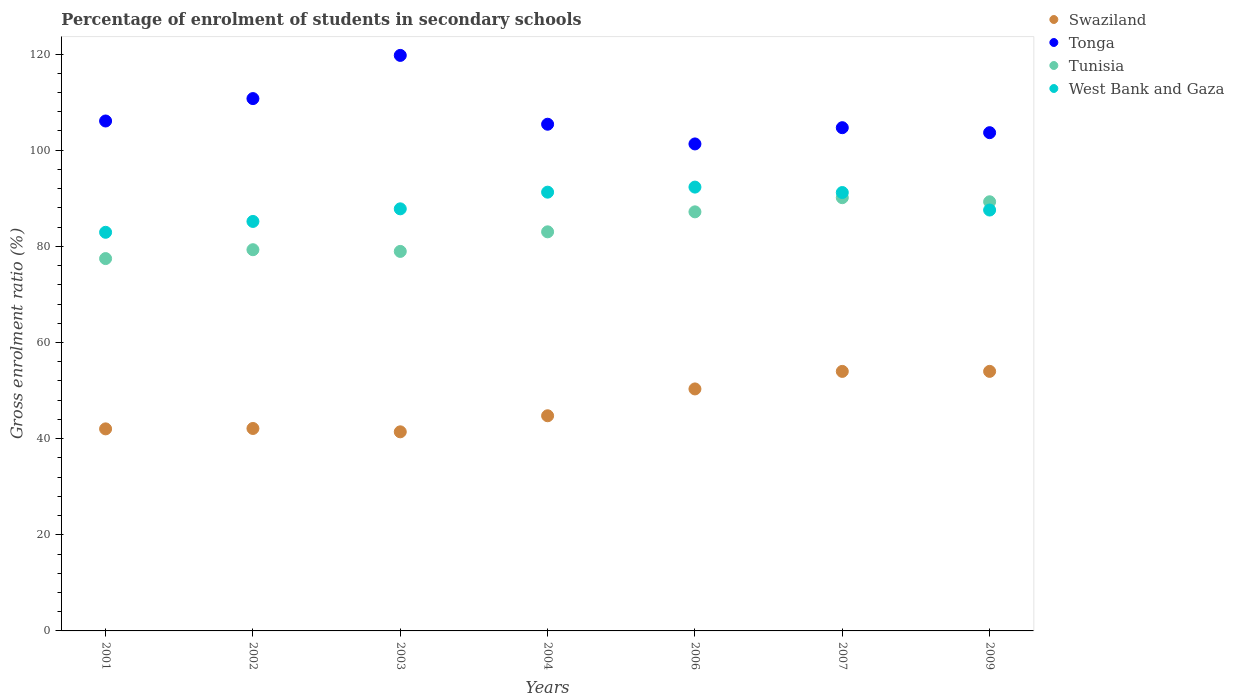How many different coloured dotlines are there?
Your answer should be compact. 4. What is the percentage of students enrolled in secondary schools in West Bank and Gaza in 2003?
Provide a succinct answer. 87.8. Across all years, what is the maximum percentage of students enrolled in secondary schools in Tonga?
Offer a terse response. 119.72. Across all years, what is the minimum percentage of students enrolled in secondary schools in West Bank and Gaza?
Offer a very short reply. 82.92. In which year was the percentage of students enrolled in secondary schools in West Bank and Gaza minimum?
Offer a terse response. 2001. What is the total percentage of students enrolled in secondary schools in Tunisia in the graph?
Offer a terse response. 585.28. What is the difference between the percentage of students enrolled in secondary schools in Tunisia in 2001 and that in 2006?
Keep it short and to the point. -9.72. What is the difference between the percentage of students enrolled in secondary schools in Tunisia in 2006 and the percentage of students enrolled in secondary schools in Swaziland in 2003?
Make the answer very short. 45.76. What is the average percentage of students enrolled in secondary schools in West Bank and Gaza per year?
Your answer should be very brief. 88.32. In the year 2007, what is the difference between the percentage of students enrolled in secondary schools in Tonga and percentage of students enrolled in secondary schools in Swaziland?
Your response must be concise. 50.7. What is the ratio of the percentage of students enrolled in secondary schools in West Bank and Gaza in 2002 to that in 2003?
Your answer should be compact. 0.97. Is the percentage of students enrolled in secondary schools in Swaziland in 2002 less than that in 2004?
Provide a succinct answer. Yes. What is the difference between the highest and the second highest percentage of students enrolled in secondary schools in Swaziland?
Make the answer very short. 0.01. What is the difference between the highest and the lowest percentage of students enrolled in secondary schools in Tunisia?
Give a very brief answer. 12.67. Is it the case that in every year, the sum of the percentage of students enrolled in secondary schools in Tonga and percentage of students enrolled in secondary schools in West Bank and Gaza  is greater than the sum of percentage of students enrolled in secondary schools in Tunisia and percentage of students enrolled in secondary schools in Swaziland?
Your answer should be very brief. Yes. Is the percentage of students enrolled in secondary schools in Tonga strictly less than the percentage of students enrolled in secondary schools in West Bank and Gaza over the years?
Your answer should be compact. No. How many dotlines are there?
Make the answer very short. 4. Are the values on the major ticks of Y-axis written in scientific E-notation?
Make the answer very short. No. Does the graph contain grids?
Offer a terse response. No. How are the legend labels stacked?
Ensure brevity in your answer.  Vertical. What is the title of the graph?
Provide a short and direct response. Percentage of enrolment of students in secondary schools. What is the label or title of the X-axis?
Ensure brevity in your answer.  Years. What is the Gross enrolment ratio (%) in Swaziland in 2001?
Your answer should be very brief. 42.03. What is the Gross enrolment ratio (%) in Tonga in 2001?
Your answer should be compact. 106.07. What is the Gross enrolment ratio (%) of Tunisia in 2001?
Offer a very short reply. 77.45. What is the Gross enrolment ratio (%) in West Bank and Gaza in 2001?
Keep it short and to the point. 82.92. What is the Gross enrolment ratio (%) of Swaziland in 2002?
Provide a short and direct response. 42.11. What is the Gross enrolment ratio (%) in Tonga in 2002?
Offer a very short reply. 110.73. What is the Gross enrolment ratio (%) of Tunisia in 2002?
Offer a very short reply. 79.3. What is the Gross enrolment ratio (%) of West Bank and Gaza in 2002?
Ensure brevity in your answer.  85.18. What is the Gross enrolment ratio (%) of Swaziland in 2003?
Your answer should be compact. 41.41. What is the Gross enrolment ratio (%) of Tonga in 2003?
Offer a terse response. 119.72. What is the Gross enrolment ratio (%) of Tunisia in 2003?
Make the answer very short. 78.95. What is the Gross enrolment ratio (%) of West Bank and Gaza in 2003?
Provide a short and direct response. 87.8. What is the Gross enrolment ratio (%) in Swaziland in 2004?
Keep it short and to the point. 44.76. What is the Gross enrolment ratio (%) in Tonga in 2004?
Your response must be concise. 105.4. What is the Gross enrolment ratio (%) in Tunisia in 2004?
Make the answer very short. 83.02. What is the Gross enrolment ratio (%) of West Bank and Gaza in 2004?
Your answer should be compact. 91.27. What is the Gross enrolment ratio (%) of Swaziland in 2006?
Ensure brevity in your answer.  50.34. What is the Gross enrolment ratio (%) in Tonga in 2006?
Make the answer very short. 101.3. What is the Gross enrolment ratio (%) of Tunisia in 2006?
Provide a short and direct response. 87.17. What is the Gross enrolment ratio (%) of West Bank and Gaza in 2006?
Offer a very short reply. 92.32. What is the Gross enrolment ratio (%) of Swaziland in 2007?
Ensure brevity in your answer.  53.98. What is the Gross enrolment ratio (%) in Tonga in 2007?
Keep it short and to the point. 104.68. What is the Gross enrolment ratio (%) of Tunisia in 2007?
Provide a short and direct response. 90.12. What is the Gross enrolment ratio (%) of West Bank and Gaza in 2007?
Your answer should be compact. 91.19. What is the Gross enrolment ratio (%) in Swaziland in 2009?
Provide a succinct answer. 53.99. What is the Gross enrolment ratio (%) in Tonga in 2009?
Your response must be concise. 103.64. What is the Gross enrolment ratio (%) in Tunisia in 2009?
Provide a short and direct response. 89.27. What is the Gross enrolment ratio (%) in West Bank and Gaza in 2009?
Offer a terse response. 87.55. Across all years, what is the maximum Gross enrolment ratio (%) of Swaziland?
Provide a succinct answer. 53.99. Across all years, what is the maximum Gross enrolment ratio (%) of Tonga?
Provide a short and direct response. 119.72. Across all years, what is the maximum Gross enrolment ratio (%) of Tunisia?
Ensure brevity in your answer.  90.12. Across all years, what is the maximum Gross enrolment ratio (%) of West Bank and Gaza?
Provide a succinct answer. 92.32. Across all years, what is the minimum Gross enrolment ratio (%) in Swaziland?
Your answer should be very brief. 41.41. Across all years, what is the minimum Gross enrolment ratio (%) in Tonga?
Make the answer very short. 101.3. Across all years, what is the minimum Gross enrolment ratio (%) of Tunisia?
Offer a terse response. 77.45. Across all years, what is the minimum Gross enrolment ratio (%) in West Bank and Gaza?
Your answer should be compact. 82.92. What is the total Gross enrolment ratio (%) of Swaziland in the graph?
Your response must be concise. 328.63. What is the total Gross enrolment ratio (%) of Tonga in the graph?
Offer a very short reply. 751.55. What is the total Gross enrolment ratio (%) in Tunisia in the graph?
Provide a succinct answer. 585.28. What is the total Gross enrolment ratio (%) in West Bank and Gaza in the graph?
Your answer should be very brief. 618.23. What is the difference between the Gross enrolment ratio (%) in Swaziland in 2001 and that in 2002?
Your answer should be compact. -0.08. What is the difference between the Gross enrolment ratio (%) of Tonga in 2001 and that in 2002?
Offer a very short reply. -4.66. What is the difference between the Gross enrolment ratio (%) of Tunisia in 2001 and that in 2002?
Give a very brief answer. -1.84. What is the difference between the Gross enrolment ratio (%) in West Bank and Gaza in 2001 and that in 2002?
Ensure brevity in your answer.  -2.26. What is the difference between the Gross enrolment ratio (%) of Swaziland in 2001 and that in 2003?
Make the answer very short. 0.61. What is the difference between the Gross enrolment ratio (%) of Tonga in 2001 and that in 2003?
Provide a short and direct response. -13.64. What is the difference between the Gross enrolment ratio (%) in Tunisia in 2001 and that in 2003?
Provide a succinct answer. -1.49. What is the difference between the Gross enrolment ratio (%) of West Bank and Gaza in 2001 and that in 2003?
Provide a short and direct response. -4.88. What is the difference between the Gross enrolment ratio (%) of Swaziland in 2001 and that in 2004?
Give a very brief answer. -2.73. What is the difference between the Gross enrolment ratio (%) of Tonga in 2001 and that in 2004?
Keep it short and to the point. 0.67. What is the difference between the Gross enrolment ratio (%) in Tunisia in 2001 and that in 2004?
Offer a very short reply. -5.56. What is the difference between the Gross enrolment ratio (%) of West Bank and Gaza in 2001 and that in 2004?
Offer a very short reply. -8.35. What is the difference between the Gross enrolment ratio (%) of Swaziland in 2001 and that in 2006?
Ensure brevity in your answer.  -8.31. What is the difference between the Gross enrolment ratio (%) in Tonga in 2001 and that in 2006?
Offer a terse response. 4.77. What is the difference between the Gross enrolment ratio (%) in Tunisia in 2001 and that in 2006?
Ensure brevity in your answer.  -9.72. What is the difference between the Gross enrolment ratio (%) of West Bank and Gaza in 2001 and that in 2006?
Offer a terse response. -9.4. What is the difference between the Gross enrolment ratio (%) of Swaziland in 2001 and that in 2007?
Ensure brevity in your answer.  -11.96. What is the difference between the Gross enrolment ratio (%) in Tonga in 2001 and that in 2007?
Offer a terse response. 1.39. What is the difference between the Gross enrolment ratio (%) of Tunisia in 2001 and that in 2007?
Your answer should be very brief. -12.67. What is the difference between the Gross enrolment ratio (%) in West Bank and Gaza in 2001 and that in 2007?
Your response must be concise. -8.27. What is the difference between the Gross enrolment ratio (%) in Swaziland in 2001 and that in 2009?
Your answer should be very brief. -11.96. What is the difference between the Gross enrolment ratio (%) of Tonga in 2001 and that in 2009?
Provide a short and direct response. 2.43. What is the difference between the Gross enrolment ratio (%) of Tunisia in 2001 and that in 2009?
Provide a succinct answer. -11.82. What is the difference between the Gross enrolment ratio (%) of West Bank and Gaza in 2001 and that in 2009?
Your response must be concise. -4.63. What is the difference between the Gross enrolment ratio (%) of Swaziland in 2002 and that in 2003?
Your response must be concise. 0.7. What is the difference between the Gross enrolment ratio (%) of Tonga in 2002 and that in 2003?
Make the answer very short. -8.99. What is the difference between the Gross enrolment ratio (%) in Tunisia in 2002 and that in 2003?
Your response must be concise. 0.35. What is the difference between the Gross enrolment ratio (%) of West Bank and Gaza in 2002 and that in 2003?
Provide a succinct answer. -2.62. What is the difference between the Gross enrolment ratio (%) of Swaziland in 2002 and that in 2004?
Offer a very short reply. -2.64. What is the difference between the Gross enrolment ratio (%) of Tonga in 2002 and that in 2004?
Offer a very short reply. 5.33. What is the difference between the Gross enrolment ratio (%) in Tunisia in 2002 and that in 2004?
Keep it short and to the point. -3.72. What is the difference between the Gross enrolment ratio (%) in West Bank and Gaza in 2002 and that in 2004?
Provide a succinct answer. -6.09. What is the difference between the Gross enrolment ratio (%) in Swaziland in 2002 and that in 2006?
Offer a terse response. -8.23. What is the difference between the Gross enrolment ratio (%) of Tonga in 2002 and that in 2006?
Keep it short and to the point. 9.43. What is the difference between the Gross enrolment ratio (%) of Tunisia in 2002 and that in 2006?
Ensure brevity in your answer.  -7.88. What is the difference between the Gross enrolment ratio (%) of West Bank and Gaza in 2002 and that in 2006?
Your answer should be very brief. -7.14. What is the difference between the Gross enrolment ratio (%) in Swaziland in 2002 and that in 2007?
Your answer should be very brief. -11.87. What is the difference between the Gross enrolment ratio (%) in Tonga in 2002 and that in 2007?
Provide a short and direct response. 6.05. What is the difference between the Gross enrolment ratio (%) of Tunisia in 2002 and that in 2007?
Provide a short and direct response. -10.82. What is the difference between the Gross enrolment ratio (%) in West Bank and Gaza in 2002 and that in 2007?
Your response must be concise. -6.01. What is the difference between the Gross enrolment ratio (%) of Swaziland in 2002 and that in 2009?
Offer a very short reply. -11.88. What is the difference between the Gross enrolment ratio (%) in Tonga in 2002 and that in 2009?
Make the answer very short. 7.09. What is the difference between the Gross enrolment ratio (%) of Tunisia in 2002 and that in 2009?
Your answer should be very brief. -9.97. What is the difference between the Gross enrolment ratio (%) in West Bank and Gaza in 2002 and that in 2009?
Give a very brief answer. -2.37. What is the difference between the Gross enrolment ratio (%) in Swaziland in 2003 and that in 2004?
Your answer should be compact. -3.34. What is the difference between the Gross enrolment ratio (%) in Tonga in 2003 and that in 2004?
Keep it short and to the point. 14.32. What is the difference between the Gross enrolment ratio (%) of Tunisia in 2003 and that in 2004?
Your answer should be compact. -4.07. What is the difference between the Gross enrolment ratio (%) in West Bank and Gaza in 2003 and that in 2004?
Offer a very short reply. -3.47. What is the difference between the Gross enrolment ratio (%) in Swaziland in 2003 and that in 2006?
Offer a very short reply. -8.92. What is the difference between the Gross enrolment ratio (%) in Tonga in 2003 and that in 2006?
Your response must be concise. 18.42. What is the difference between the Gross enrolment ratio (%) in Tunisia in 2003 and that in 2006?
Make the answer very short. -8.23. What is the difference between the Gross enrolment ratio (%) of West Bank and Gaza in 2003 and that in 2006?
Provide a short and direct response. -4.52. What is the difference between the Gross enrolment ratio (%) in Swaziland in 2003 and that in 2007?
Ensure brevity in your answer.  -12.57. What is the difference between the Gross enrolment ratio (%) of Tonga in 2003 and that in 2007?
Offer a terse response. 15.04. What is the difference between the Gross enrolment ratio (%) in Tunisia in 2003 and that in 2007?
Make the answer very short. -11.18. What is the difference between the Gross enrolment ratio (%) of West Bank and Gaza in 2003 and that in 2007?
Provide a short and direct response. -3.39. What is the difference between the Gross enrolment ratio (%) of Swaziland in 2003 and that in 2009?
Offer a terse response. -12.58. What is the difference between the Gross enrolment ratio (%) in Tonga in 2003 and that in 2009?
Your answer should be compact. 16.07. What is the difference between the Gross enrolment ratio (%) in Tunisia in 2003 and that in 2009?
Ensure brevity in your answer.  -10.32. What is the difference between the Gross enrolment ratio (%) of West Bank and Gaza in 2003 and that in 2009?
Your answer should be very brief. 0.25. What is the difference between the Gross enrolment ratio (%) in Swaziland in 2004 and that in 2006?
Your answer should be very brief. -5.58. What is the difference between the Gross enrolment ratio (%) of Tonga in 2004 and that in 2006?
Provide a succinct answer. 4.1. What is the difference between the Gross enrolment ratio (%) of Tunisia in 2004 and that in 2006?
Your answer should be very brief. -4.16. What is the difference between the Gross enrolment ratio (%) in West Bank and Gaza in 2004 and that in 2006?
Make the answer very short. -1.05. What is the difference between the Gross enrolment ratio (%) in Swaziland in 2004 and that in 2007?
Provide a succinct answer. -9.23. What is the difference between the Gross enrolment ratio (%) of Tonga in 2004 and that in 2007?
Your response must be concise. 0.72. What is the difference between the Gross enrolment ratio (%) in Tunisia in 2004 and that in 2007?
Offer a terse response. -7.1. What is the difference between the Gross enrolment ratio (%) in West Bank and Gaza in 2004 and that in 2007?
Keep it short and to the point. 0.08. What is the difference between the Gross enrolment ratio (%) in Swaziland in 2004 and that in 2009?
Your answer should be very brief. -9.24. What is the difference between the Gross enrolment ratio (%) in Tonga in 2004 and that in 2009?
Your response must be concise. 1.76. What is the difference between the Gross enrolment ratio (%) in Tunisia in 2004 and that in 2009?
Your answer should be compact. -6.25. What is the difference between the Gross enrolment ratio (%) in West Bank and Gaza in 2004 and that in 2009?
Offer a terse response. 3.72. What is the difference between the Gross enrolment ratio (%) in Swaziland in 2006 and that in 2007?
Provide a short and direct response. -3.65. What is the difference between the Gross enrolment ratio (%) in Tonga in 2006 and that in 2007?
Offer a very short reply. -3.38. What is the difference between the Gross enrolment ratio (%) of Tunisia in 2006 and that in 2007?
Your answer should be very brief. -2.95. What is the difference between the Gross enrolment ratio (%) in West Bank and Gaza in 2006 and that in 2007?
Give a very brief answer. 1.13. What is the difference between the Gross enrolment ratio (%) of Swaziland in 2006 and that in 2009?
Provide a succinct answer. -3.65. What is the difference between the Gross enrolment ratio (%) of Tonga in 2006 and that in 2009?
Offer a very short reply. -2.34. What is the difference between the Gross enrolment ratio (%) of Tunisia in 2006 and that in 2009?
Provide a succinct answer. -2.1. What is the difference between the Gross enrolment ratio (%) of West Bank and Gaza in 2006 and that in 2009?
Give a very brief answer. 4.77. What is the difference between the Gross enrolment ratio (%) in Swaziland in 2007 and that in 2009?
Ensure brevity in your answer.  -0.01. What is the difference between the Gross enrolment ratio (%) in Tonga in 2007 and that in 2009?
Keep it short and to the point. 1.04. What is the difference between the Gross enrolment ratio (%) of Tunisia in 2007 and that in 2009?
Your answer should be very brief. 0.85. What is the difference between the Gross enrolment ratio (%) in West Bank and Gaza in 2007 and that in 2009?
Provide a short and direct response. 3.64. What is the difference between the Gross enrolment ratio (%) in Swaziland in 2001 and the Gross enrolment ratio (%) in Tonga in 2002?
Ensure brevity in your answer.  -68.7. What is the difference between the Gross enrolment ratio (%) of Swaziland in 2001 and the Gross enrolment ratio (%) of Tunisia in 2002?
Your answer should be compact. -37.27. What is the difference between the Gross enrolment ratio (%) in Swaziland in 2001 and the Gross enrolment ratio (%) in West Bank and Gaza in 2002?
Provide a succinct answer. -43.15. What is the difference between the Gross enrolment ratio (%) in Tonga in 2001 and the Gross enrolment ratio (%) in Tunisia in 2002?
Your answer should be compact. 26.78. What is the difference between the Gross enrolment ratio (%) in Tonga in 2001 and the Gross enrolment ratio (%) in West Bank and Gaza in 2002?
Provide a succinct answer. 20.9. What is the difference between the Gross enrolment ratio (%) of Tunisia in 2001 and the Gross enrolment ratio (%) of West Bank and Gaza in 2002?
Offer a very short reply. -7.73. What is the difference between the Gross enrolment ratio (%) of Swaziland in 2001 and the Gross enrolment ratio (%) of Tonga in 2003?
Keep it short and to the point. -77.69. What is the difference between the Gross enrolment ratio (%) of Swaziland in 2001 and the Gross enrolment ratio (%) of Tunisia in 2003?
Give a very brief answer. -36.92. What is the difference between the Gross enrolment ratio (%) in Swaziland in 2001 and the Gross enrolment ratio (%) in West Bank and Gaza in 2003?
Provide a short and direct response. -45.77. What is the difference between the Gross enrolment ratio (%) in Tonga in 2001 and the Gross enrolment ratio (%) in Tunisia in 2003?
Offer a terse response. 27.13. What is the difference between the Gross enrolment ratio (%) of Tonga in 2001 and the Gross enrolment ratio (%) of West Bank and Gaza in 2003?
Offer a terse response. 18.27. What is the difference between the Gross enrolment ratio (%) in Tunisia in 2001 and the Gross enrolment ratio (%) in West Bank and Gaza in 2003?
Give a very brief answer. -10.35. What is the difference between the Gross enrolment ratio (%) in Swaziland in 2001 and the Gross enrolment ratio (%) in Tonga in 2004?
Give a very brief answer. -63.37. What is the difference between the Gross enrolment ratio (%) in Swaziland in 2001 and the Gross enrolment ratio (%) in Tunisia in 2004?
Your response must be concise. -40.99. What is the difference between the Gross enrolment ratio (%) of Swaziland in 2001 and the Gross enrolment ratio (%) of West Bank and Gaza in 2004?
Provide a succinct answer. -49.24. What is the difference between the Gross enrolment ratio (%) of Tonga in 2001 and the Gross enrolment ratio (%) of Tunisia in 2004?
Ensure brevity in your answer.  23.06. What is the difference between the Gross enrolment ratio (%) of Tonga in 2001 and the Gross enrolment ratio (%) of West Bank and Gaza in 2004?
Your answer should be very brief. 14.81. What is the difference between the Gross enrolment ratio (%) of Tunisia in 2001 and the Gross enrolment ratio (%) of West Bank and Gaza in 2004?
Offer a very short reply. -13.81. What is the difference between the Gross enrolment ratio (%) in Swaziland in 2001 and the Gross enrolment ratio (%) in Tonga in 2006?
Provide a short and direct response. -59.27. What is the difference between the Gross enrolment ratio (%) in Swaziland in 2001 and the Gross enrolment ratio (%) in Tunisia in 2006?
Provide a short and direct response. -45.15. What is the difference between the Gross enrolment ratio (%) of Swaziland in 2001 and the Gross enrolment ratio (%) of West Bank and Gaza in 2006?
Your response must be concise. -50.29. What is the difference between the Gross enrolment ratio (%) in Tonga in 2001 and the Gross enrolment ratio (%) in Tunisia in 2006?
Provide a short and direct response. 18.9. What is the difference between the Gross enrolment ratio (%) in Tonga in 2001 and the Gross enrolment ratio (%) in West Bank and Gaza in 2006?
Make the answer very short. 13.75. What is the difference between the Gross enrolment ratio (%) in Tunisia in 2001 and the Gross enrolment ratio (%) in West Bank and Gaza in 2006?
Make the answer very short. -14.87. What is the difference between the Gross enrolment ratio (%) in Swaziland in 2001 and the Gross enrolment ratio (%) in Tonga in 2007?
Make the answer very short. -62.65. What is the difference between the Gross enrolment ratio (%) in Swaziland in 2001 and the Gross enrolment ratio (%) in Tunisia in 2007?
Give a very brief answer. -48.09. What is the difference between the Gross enrolment ratio (%) in Swaziland in 2001 and the Gross enrolment ratio (%) in West Bank and Gaza in 2007?
Your response must be concise. -49.16. What is the difference between the Gross enrolment ratio (%) in Tonga in 2001 and the Gross enrolment ratio (%) in Tunisia in 2007?
Ensure brevity in your answer.  15.95. What is the difference between the Gross enrolment ratio (%) of Tonga in 2001 and the Gross enrolment ratio (%) of West Bank and Gaza in 2007?
Make the answer very short. 14.88. What is the difference between the Gross enrolment ratio (%) in Tunisia in 2001 and the Gross enrolment ratio (%) in West Bank and Gaza in 2007?
Give a very brief answer. -13.74. What is the difference between the Gross enrolment ratio (%) in Swaziland in 2001 and the Gross enrolment ratio (%) in Tonga in 2009?
Provide a succinct answer. -61.62. What is the difference between the Gross enrolment ratio (%) in Swaziland in 2001 and the Gross enrolment ratio (%) in Tunisia in 2009?
Offer a terse response. -47.24. What is the difference between the Gross enrolment ratio (%) of Swaziland in 2001 and the Gross enrolment ratio (%) of West Bank and Gaza in 2009?
Keep it short and to the point. -45.52. What is the difference between the Gross enrolment ratio (%) of Tonga in 2001 and the Gross enrolment ratio (%) of Tunisia in 2009?
Ensure brevity in your answer.  16.8. What is the difference between the Gross enrolment ratio (%) of Tonga in 2001 and the Gross enrolment ratio (%) of West Bank and Gaza in 2009?
Make the answer very short. 18.52. What is the difference between the Gross enrolment ratio (%) of Tunisia in 2001 and the Gross enrolment ratio (%) of West Bank and Gaza in 2009?
Provide a succinct answer. -10.1. What is the difference between the Gross enrolment ratio (%) of Swaziland in 2002 and the Gross enrolment ratio (%) of Tonga in 2003?
Ensure brevity in your answer.  -77.61. What is the difference between the Gross enrolment ratio (%) in Swaziland in 2002 and the Gross enrolment ratio (%) in Tunisia in 2003?
Your answer should be very brief. -36.83. What is the difference between the Gross enrolment ratio (%) in Swaziland in 2002 and the Gross enrolment ratio (%) in West Bank and Gaza in 2003?
Keep it short and to the point. -45.69. What is the difference between the Gross enrolment ratio (%) in Tonga in 2002 and the Gross enrolment ratio (%) in Tunisia in 2003?
Your answer should be compact. 31.79. What is the difference between the Gross enrolment ratio (%) of Tonga in 2002 and the Gross enrolment ratio (%) of West Bank and Gaza in 2003?
Provide a short and direct response. 22.93. What is the difference between the Gross enrolment ratio (%) of Tunisia in 2002 and the Gross enrolment ratio (%) of West Bank and Gaza in 2003?
Offer a very short reply. -8.5. What is the difference between the Gross enrolment ratio (%) in Swaziland in 2002 and the Gross enrolment ratio (%) in Tonga in 2004?
Provide a short and direct response. -63.29. What is the difference between the Gross enrolment ratio (%) in Swaziland in 2002 and the Gross enrolment ratio (%) in Tunisia in 2004?
Provide a short and direct response. -40.9. What is the difference between the Gross enrolment ratio (%) of Swaziland in 2002 and the Gross enrolment ratio (%) of West Bank and Gaza in 2004?
Make the answer very short. -49.16. What is the difference between the Gross enrolment ratio (%) in Tonga in 2002 and the Gross enrolment ratio (%) in Tunisia in 2004?
Your answer should be compact. 27.72. What is the difference between the Gross enrolment ratio (%) of Tonga in 2002 and the Gross enrolment ratio (%) of West Bank and Gaza in 2004?
Provide a short and direct response. 19.47. What is the difference between the Gross enrolment ratio (%) in Tunisia in 2002 and the Gross enrolment ratio (%) in West Bank and Gaza in 2004?
Provide a short and direct response. -11.97. What is the difference between the Gross enrolment ratio (%) of Swaziland in 2002 and the Gross enrolment ratio (%) of Tonga in 2006?
Your answer should be very brief. -59.19. What is the difference between the Gross enrolment ratio (%) of Swaziland in 2002 and the Gross enrolment ratio (%) of Tunisia in 2006?
Provide a succinct answer. -45.06. What is the difference between the Gross enrolment ratio (%) in Swaziland in 2002 and the Gross enrolment ratio (%) in West Bank and Gaza in 2006?
Your answer should be very brief. -50.21. What is the difference between the Gross enrolment ratio (%) in Tonga in 2002 and the Gross enrolment ratio (%) in Tunisia in 2006?
Keep it short and to the point. 23.56. What is the difference between the Gross enrolment ratio (%) in Tonga in 2002 and the Gross enrolment ratio (%) in West Bank and Gaza in 2006?
Your response must be concise. 18.41. What is the difference between the Gross enrolment ratio (%) in Tunisia in 2002 and the Gross enrolment ratio (%) in West Bank and Gaza in 2006?
Ensure brevity in your answer.  -13.02. What is the difference between the Gross enrolment ratio (%) of Swaziland in 2002 and the Gross enrolment ratio (%) of Tonga in 2007?
Keep it short and to the point. -62.57. What is the difference between the Gross enrolment ratio (%) of Swaziland in 2002 and the Gross enrolment ratio (%) of Tunisia in 2007?
Provide a short and direct response. -48.01. What is the difference between the Gross enrolment ratio (%) in Swaziland in 2002 and the Gross enrolment ratio (%) in West Bank and Gaza in 2007?
Your response must be concise. -49.08. What is the difference between the Gross enrolment ratio (%) in Tonga in 2002 and the Gross enrolment ratio (%) in Tunisia in 2007?
Provide a short and direct response. 20.61. What is the difference between the Gross enrolment ratio (%) in Tonga in 2002 and the Gross enrolment ratio (%) in West Bank and Gaza in 2007?
Give a very brief answer. 19.54. What is the difference between the Gross enrolment ratio (%) of Tunisia in 2002 and the Gross enrolment ratio (%) of West Bank and Gaza in 2007?
Your answer should be very brief. -11.9. What is the difference between the Gross enrolment ratio (%) in Swaziland in 2002 and the Gross enrolment ratio (%) in Tonga in 2009?
Offer a very short reply. -61.53. What is the difference between the Gross enrolment ratio (%) in Swaziland in 2002 and the Gross enrolment ratio (%) in Tunisia in 2009?
Offer a terse response. -47.16. What is the difference between the Gross enrolment ratio (%) in Swaziland in 2002 and the Gross enrolment ratio (%) in West Bank and Gaza in 2009?
Provide a short and direct response. -45.44. What is the difference between the Gross enrolment ratio (%) of Tonga in 2002 and the Gross enrolment ratio (%) of Tunisia in 2009?
Keep it short and to the point. 21.46. What is the difference between the Gross enrolment ratio (%) of Tonga in 2002 and the Gross enrolment ratio (%) of West Bank and Gaza in 2009?
Keep it short and to the point. 23.18. What is the difference between the Gross enrolment ratio (%) in Tunisia in 2002 and the Gross enrolment ratio (%) in West Bank and Gaza in 2009?
Provide a short and direct response. -8.25. What is the difference between the Gross enrolment ratio (%) in Swaziland in 2003 and the Gross enrolment ratio (%) in Tonga in 2004?
Keep it short and to the point. -63.99. What is the difference between the Gross enrolment ratio (%) in Swaziland in 2003 and the Gross enrolment ratio (%) in Tunisia in 2004?
Provide a succinct answer. -41.6. What is the difference between the Gross enrolment ratio (%) of Swaziland in 2003 and the Gross enrolment ratio (%) of West Bank and Gaza in 2004?
Make the answer very short. -49.85. What is the difference between the Gross enrolment ratio (%) of Tonga in 2003 and the Gross enrolment ratio (%) of Tunisia in 2004?
Offer a very short reply. 36.7. What is the difference between the Gross enrolment ratio (%) of Tonga in 2003 and the Gross enrolment ratio (%) of West Bank and Gaza in 2004?
Offer a terse response. 28.45. What is the difference between the Gross enrolment ratio (%) in Tunisia in 2003 and the Gross enrolment ratio (%) in West Bank and Gaza in 2004?
Provide a succinct answer. -12.32. What is the difference between the Gross enrolment ratio (%) of Swaziland in 2003 and the Gross enrolment ratio (%) of Tonga in 2006?
Your answer should be compact. -59.89. What is the difference between the Gross enrolment ratio (%) of Swaziland in 2003 and the Gross enrolment ratio (%) of Tunisia in 2006?
Keep it short and to the point. -45.76. What is the difference between the Gross enrolment ratio (%) of Swaziland in 2003 and the Gross enrolment ratio (%) of West Bank and Gaza in 2006?
Your answer should be very brief. -50.91. What is the difference between the Gross enrolment ratio (%) of Tonga in 2003 and the Gross enrolment ratio (%) of Tunisia in 2006?
Provide a short and direct response. 32.54. What is the difference between the Gross enrolment ratio (%) of Tonga in 2003 and the Gross enrolment ratio (%) of West Bank and Gaza in 2006?
Provide a short and direct response. 27.4. What is the difference between the Gross enrolment ratio (%) in Tunisia in 2003 and the Gross enrolment ratio (%) in West Bank and Gaza in 2006?
Provide a succinct answer. -13.38. What is the difference between the Gross enrolment ratio (%) of Swaziland in 2003 and the Gross enrolment ratio (%) of Tonga in 2007?
Offer a very short reply. -63.27. What is the difference between the Gross enrolment ratio (%) in Swaziland in 2003 and the Gross enrolment ratio (%) in Tunisia in 2007?
Your response must be concise. -48.71. What is the difference between the Gross enrolment ratio (%) of Swaziland in 2003 and the Gross enrolment ratio (%) of West Bank and Gaza in 2007?
Offer a terse response. -49.78. What is the difference between the Gross enrolment ratio (%) of Tonga in 2003 and the Gross enrolment ratio (%) of Tunisia in 2007?
Your response must be concise. 29.6. What is the difference between the Gross enrolment ratio (%) of Tonga in 2003 and the Gross enrolment ratio (%) of West Bank and Gaza in 2007?
Ensure brevity in your answer.  28.53. What is the difference between the Gross enrolment ratio (%) in Tunisia in 2003 and the Gross enrolment ratio (%) in West Bank and Gaza in 2007?
Make the answer very short. -12.25. What is the difference between the Gross enrolment ratio (%) in Swaziland in 2003 and the Gross enrolment ratio (%) in Tonga in 2009?
Provide a succinct answer. -62.23. What is the difference between the Gross enrolment ratio (%) of Swaziland in 2003 and the Gross enrolment ratio (%) of Tunisia in 2009?
Provide a short and direct response. -47.86. What is the difference between the Gross enrolment ratio (%) of Swaziland in 2003 and the Gross enrolment ratio (%) of West Bank and Gaza in 2009?
Your answer should be compact. -46.14. What is the difference between the Gross enrolment ratio (%) in Tonga in 2003 and the Gross enrolment ratio (%) in Tunisia in 2009?
Give a very brief answer. 30.45. What is the difference between the Gross enrolment ratio (%) in Tonga in 2003 and the Gross enrolment ratio (%) in West Bank and Gaza in 2009?
Give a very brief answer. 32.17. What is the difference between the Gross enrolment ratio (%) in Tunisia in 2003 and the Gross enrolment ratio (%) in West Bank and Gaza in 2009?
Provide a succinct answer. -8.61. What is the difference between the Gross enrolment ratio (%) of Swaziland in 2004 and the Gross enrolment ratio (%) of Tonga in 2006?
Offer a terse response. -56.54. What is the difference between the Gross enrolment ratio (%) of Swaziland in 2004 and the Gross enrolment ratio (%) of Tunisia in 2006?
Provide a short and direct response. -42.42. What is the difference between the Gross enrolment ratio (%) of Swaziland in 2004 and the Gross enrolment ratio (%) of West Bank and Gaza in 2006?
Give a very brief answer. -47.56. What is the difference between the Gross enrolment ratio (%) in Tonga in 2004 and the Gross enrolment ratio (%) in Tunisia in 2006?
Your answer should be compact. 18.23. What is the difference between the Gross enrolment ratio (%) in Tonga in 2004 and the Gross enrolment ratio (%) in West Bank and Gaza in 2006?
Provide a short and direct response. 13.08. What is the difference between the Gross enrolment ratio (%) in Tunisia in 2004 and the Gross enrolment ratio (%) in West Bank and Gaza in 2006?
Give a very brief answer. -9.3. What is the difference between the Gross enrolment ratio (%) in Swaziland in 2004 and the Gross enrolment ratio (%) in Tonga in 2007?
Keep it short and to the point. -59.92. What is the difference between the Gross enrolment ratio (%) in Swaziland in 2004 and the Gross enrolment ratio (%) in Tunisia in 2007?
Offer a terse response. -45.37. What is the difference between the Gross enrolment ratio (%) in Swaziland in 2004 and the Gross enrolment ratio (%) in West Bank and Gaza in 2007?
Give a very brief answer. -46.44. What is the difference between the Gross enrolment ratio (%) of Tonga in 2004 and the Gross enrolment ratio (%) of Tunisia in 2007?
Your response must be concise. 15.28. What is the difference between the Gross enrolment ratio (%) in Tonga in 2004 and the Gross enrolment ratio (%) in West Bank and Gaza in 2007?
Your response must be concise. 14.21. What is the difference between the Gross enrolment ratio (%) in Tunisia in 2004 and the Gross enrolment ratio (%) in West Bank and Gaza in 2007?
Provide a succinct answer. -8.18. What is the difference between the Gross enrolment ratio (%) of Swaziland in 2004 and the Gross enrolment ratio (%) of Tonga in 2009?
Offer a very short reply. -58.89. What is the difference between the Gross enrolment ratio (%) of Swaziland in 2004 and the Gross enrolment ratio (%) of Tunisia in 2009?
Your answer should be compact. -44.51. What is the difference between the Gross enrolment ratio (%) in Swaziland in 2004 and the Gross enrolment ratio (%) in West Bank and Gaza in 2009?
Offer a very short reply. -42.8. What is the difference between the Gross enrolment ratio (%) of Tonga in 2004 and the Gross enrolment ratio (%) of Tunisia in 2009?
Provide a short and direct response. 16.13. What is the difference between the Gross enrolment ratio (%) of Tonga in 2004 and the Gross enrolment ratio (%) of West Bank and Gaza in 2009?
Offer a terse response. 17.85. What is the difference between the Gross enrolment ratio (%) in Tunisia in 2004 and the Gross enrolment ratio (%) in West Bank and Gaza in 2009?
Make the answer very short. -4.53. What is the difference between the Gross enrolment ratio (%) in Swaziland in 2006 and the Gross enrolment ratio (%) in Tonga in 2007?
Offer a terse response. -54.34. What is the difference between the Gross enrolment ratio (%) of Swaziland in 2006 and the Gross enrolment ratio (%) of Tunisia in 2007?
Your answer should be compact. -39.78. What is the difference between the Gross enrolment ratio (%) in Swaziland in 2006 and the Gross enrolment ratio (%) in West Bank and Gaza in 2007?
Ensure brevity in your answer.  -40.86. What is the difference between the Gross enrolment ratio (%) of Tonga in 2006 and the Gross enrolment ratio (%) of Tunisia in 2007?
Provide a succinct answer. 11.18. What is the difference between the Gross enrolment ratio (%) of Tonga in 2006 and the Gross enrolment ratio (%) of West Bank and Gaza in 2007?
Give a very brief answer. 10.11. What is the difference between the Gross enrolment ratio (%) in Tunisia in 2006 and the Gross enrolment ratio (%) in West Bank and Gaza in 2007?
Provide a short and direct response. -4.02. What is the difference between the Gross enrolment ratio (%) of Swaziland in 2006 and the Gross enrolment ratio (%) of Tonga in 2009?
Provide a succinct answer. -53.31. What is the difference between the Gross enrolment ratio (%) in Swaziland in 2006 and the Gross enrolment ratio (%) in Tunisia in 2009?
Provide a succinct answer. -38.93. What is the difference between the Gross enrolment ratio (%) of Swaziland in 2006 and the Gross enrolment ratio (%) of West Bank and Gaza in 2009?
Provide a short and direct response. -37.21. What is the difference between the Gross enrolment ratio (%) of Tonga in 2006 and the Gross enrolment ratio (%) of Tunisia in 2009?
Your answer should be compact. 12.03. What is the difference between the Gross enrolment ratio (%) in Tonga in 2006 and the Gross enrolment ratio (%) in West Bank and Gaza in 2009?
Keep it short and to the point. 13.75. What is the difference between the Gross enrolment ratio (%) in Tunisia in 2006 and the Gross enrolment ratio (%) in West Bank and Gaza in 2009?
Your answer should be very brief. -0.38. What is the difference between the Gross enrolment ratio (%) in Swaziland in 2007 and the Gross enrolment ratio (%) in Tonga in 2009?
Your response must be concise. -49.66. What is the difference between the Gross enrolment ratio (%) of Swaziland in 2007 and the Gross enrolment ratio (%) of Tunisia in 2009?
Ensure brevity in your answer.  -35.29. What is the difference between the Gross enrolment ratio (%) of Swaziland in 2007 and the Gross enrolment ratio (%) of West Bank and Gaza in 2009?
Your answer should be compact. -33.57. What is the difference between the Gross enrolment ratio (%) of Tonga in 2007 and the Gross enrolment ratio (%) of Tunisia in 2009?
Provide a succinct answer. 15.41. What is the difference between the Gross enrolment ratio (%) in Tonga in 2007 and the Gross enrolment ratio (%) in West Bank and Gaza in 2009?
Make the answer very short. 17.13. What is the difference between the Gross enrolment ratio (%) of Tunisia in 2007 and the Gross enrolment ratio (%) of West Bank and Gaza in 2009?
Offer a very short reply. 2.57. What is the average Gross enrolment ratio (%) of Swaziland per year?
Offer a terse response. 46.95. What is the average Gross enrolment ratio (%) in Tonga per year?
Offer a very short reply. 107.36. What is the average Gross enrolment ratio (%) in Tunisia per year?
Provide a short and direct response. 83.61. What is the average Gross enrolment ratio (%) of West Bank and Gaza per year?
Offer a terse response. 88.32. In the year 2001, what is the difference between the Gross enrolment ratio (%) of Swaziland and Gross enrolment ratio (%) of Tonga?
Your response must be concise. -64.05. In the year 2001, what is the difference between the Gross enrolment ratio (%) in Swaziland and Gross enrolment ratio (%) in Tunisia?
Provide a succinct answer. -35.42. In the year 2001, what is the difference between the Gross enrolment ratio (%) in Swaziland and Gross enrolment ratio (%) in West Bank and Gaza?
Ensure brevity in your answer.  -40.89. In the year 2001, what is the difference between the Gross enrolment ratio (%) of Tonga and Gross enrolment ratio (%) of Tunisia?
Keep it short and to the point. 28.62. In the year 2001, what is the difference between the Gross enrolment ratio (%) of Tonga and Gross enrolment ratio (%) of West Bank and Gaza?
Give a very brief answer. 23.15. In the year 2001, what is the difference between the Gross enrolment ratio (%) in Tunisia and Gross enrolment ratio (%) in West Bank and Gaza?
Your answer should be very brief. -5.47. In the year 2002, what is the difference between the Gross enrolment ratio (%) in Swaziland and Gross enrolment ratio (%) in Tonga?
Your answer should be very brief. -68.62. In the year 2002, what is the difference between the Gross enrolment ratio (%) of Swaziland and Gross enrolment ratio (%) of Tunisia?
Make the answer very short. -37.19. In the year 2002, what is the difference between the Gross enrolment ratio (%) in Swaziland and Gross enrolment ratio (%) in West Bank and Gaza?
Ensure brevity in your answer.  -43.07. In the year 2002, what is the difference between the Gross enrolment ratio (%) in Tonga and Gross enrolment ratio (%) in Tunisia?
Keep it short and to the point. 31.44. In the year 2002, what is the difference between the Gross enrolment ratio (%) of Tonga and Gross enrolment ratio (%) of West Bank and Gaza?
Offer a terse response. 25.55. In the year 2002, what is the difference between the Gross enrolment ratio (%) of Tunisia and Gross enrolment ratio (%) of West Bank and Gaza?
Your answer should be very brief. -5.88. In the year 2003, what is the difference between the Gross enrolment ratio (%) of Swaziland and Gross enrolment ratio (%) of Tonga?
Your answer should be compact. -78.3. In the year 2003, what is the difference between the Gross enrolment ratio (%) in Swaziland and Gross enrolment ratio (%) in Tunisia?
Make the answer very short. -37.53. In the year 2003, what is the difference between the Gross enrolment ratio (%) of Swaziland and Gross enrolment ratio (%) of West Bank and Gaza?
Give a very brief answer. -46.39. In the year 2003, what is the difference between the Gross enrolment ratio (%) of Tonga and Gross enrolment ratio (%) of Tunisia?
Your answer should be very brief. 40.77. In the year 2003, what is the difference between the Gross enrolment ratio (%) of Tonga and Gross enrolment ratio (%) of West Bank and Gaza?
Your answer should be very brief. 31.92. In the year 2003, what is the difference between the Gross enrolment ratio (%) in Tunisia and Gross enrolment ratio (%) in West Bank and Gaza?
Offer a terse response. -8.85. In the year 2004, what is the difference between the Gross enrolment ratio (%) in Swaziland and Gross enrolment ratio (%) in Tonga?
Provide a succinct answer. -60.64. In the year 2004, what is the difference between the Gross enrolment ratio (%) of Swaziland and Gross enrolment ratio (%) of Tunisia?
Your answer should be compact. -38.26. In the year 2004, what is the difference between the Gross enrolment ratio (%) of Swaziland and Gross enrolment ratio (%) of West Bank and Gaza?
Give a very brief answer. -46.51. In the year 2004, what is the difference between the Gross enrolment ratio (%) in Tonga and Gross enrolment ratio (%) in Tunisia?
Your response must be concise. 22.38. In the year 2004, what is the difference between the Gross enrolment ratio (%) in Tonga and Gross enrolment ratio (%) in West Bank and Gaza?
Provide a succinct answer. 14.13. In the year 2004, what is the difference between the Gross enrolment ratio (%) in Tunisia and Gross enrolment ratio (%) in West Bank and Gaza?
Your answer should be compact. -8.25. In the year 2006, what is the difference between the Gross enrolment ratio (%) of Swaziland and Gross enrolment ratio (%) of Tonga?
Offer a very short reply. -50.96. In the year 2006, what is the difference between the Gross enrolment ratio (%) of Swaziland and Gross enrolment ratio (%) of Tunisia?
Keep it short and to the point. -36.84. In the year 2006, what is the difference between the Gross enrolment ratio (%) in Swaziland and Gross enrolment ratio (%) in West Bank and Gaza?
Offer a very short reply. -41.98. In the year 2006, what is the difference between the Gross enrolment ratio (%) of Tonga and Gross enrolment ratio (%) of Tunisia?
Keep it short and to the point. 14.13. In the year 2006, what is the difference between the Gross enrolment ratio (%) of Tonga and Gross enrolment ratio (%) of West Bank and Gaza?
Provide a short and direct response. 8.98. In the year 2006, what is the difference between the Gross enrolment ratio (%) in Tunisia and Gross enrolment ratio (%) in West Bank and Gaza?
Ensure brevity in your answer.  -5.15. In the year 2007, what is the difference between the Gross enrolment ratio (%) in Swaziland and Gross enrolment ratio (%) in Tonga?
Offer a terse response. -50.7. In the year 2007, what is the difference between the Gross enrolment ratio (%) in Swaziland and Gross enrolment ratio (%) in Tunisia?
Offer a very short reply. -36.14. In the year 2007, what is the difference between the Gross enrolment ratio (%) in Swaziland and Gross enrolment ratio (%) in West Bank and Gaza?
Your answer should be very brief. -37.21. In the year 2007, what is the difference between the Gross enrolment ratio (%) of Tonga and Gross enrolment ratio (%) of Tunisia?
Give a very brief answer. 14.56. In the year 2007, what is the difference between the Gross enrolment ratio (%) in Tonga and Gross enrolment ratio (%) in West Bank and Gaza?
Ensure brevity in your answer.  13.49. In the year 2007, what is the difference between the Gross enrolment ratio (%) of Tunisia and Gross enrolment ratio (%) of West Bank and Gaza?
Provide a succinct answer. -1.07. In the year 2009, what is the difference between the Gross enrolment ratio (%) of Swaziland and Gross enrolment ratio (%) of Tonga?
Your response must be concise. -49.65. In the year 2009, what is the difference between the Gross enrolment ratio (%) of Swaziland and Gross enrolment ratio (%) of Tunisia?
Offer a terse response. -35.28. In the year 2009, what is the difference between the Gross enrolment ratio (%) in Swaziland and Gross enrolment ratio (%) in West Bank and Gaza?
Keep it short and to the point. -33.56. In the year 2009, what is the difference between the Gross enrolment ratio (%) of Tonga and Gross enrolment ratio (%) of Tunisia?
Offer a very short reply. 14.37. In the year 2009, what is the difference between the Gross enrolment ratio (%) in Tonga and Gross enrolment ratio (%) in West Bank and Gaza?
Offer a very short reply. 16.09. In the year 2009, what is the difference between the Gross enrolment ratio (%) of Tunisia and Gross enrolment ratio (%) of West Bank and Gaza?
Your answer should be compact. 1.72. What is the ratio of the Gross enrolment ratio (%) in Tonga in 2001 to that in 2002?
Give a very brief answer. 0.96. What is the ratio of the Gross enrolment ratio (%) of Tunisia in 2001 to that in 2002?
Keep it short and to the point. 0.98. What is the ratio of the Gross enrolment ratio (%) in West Bank and Gaza in 2001 to that in 2002?
Give a very brief answer. 0.97. What is the ratio of the Gross enrolment ratio (%) of Swaziland in 2001 to that in 2003?
Provide a succinct answer. 1.01. What is the ratio of the Gross enrolment ratio (%) of Tonga in 2001 to that in 2003?
Offer a very short reply. 0.89. What is the ratio of the Gross enrolment ratio (%) in Tunisia in 2001 to that in 2003?
Offer a very short reply. 0.98. What is the ratio of the Gross enrolment ratio (%) of West Bank and Gaza in 2001 to that in 2003?
Make the answer very short. 0.94. What is the ratio of the Gross enrolment ratio (%) in Swaziland in 2001 to that in 2004?
Give a very brief answer. 0.94. What is the ratio of the Gross enrolment ratio (%) of Tonga in 2001 to that in 2004?
Offer a very short reply. 1.01. What is the ratio of the Gross enrolment ratio (%) of Tunisia in 2001 to that in 2004?
Your answer should be very brief. 0.93. What is the ratio of the Gross enrolment ratio (%) of West Bank and Gaza in 2001 to that in 2004?
Give a very brief answer. 0.91. What is the ratio of the Gross enrolment ratio (%) in Swaziland in 2001 to that in 2006?
Your answer should be very brief. 0.83. What is the ratio of the Gross enrolment ratio (%) in Tonga in 2001 to that in 2006?
Provide a succinct answer. 1.05. What is the ratio of the Gross enrolment ratio (%) of Tunisia in 2001 to that in 2006?
Your response must be concise. 0.89. What is the ratio of the Gross enrolment ratio (%) of West Bank and Gaza in 2001 to that in 2006?
Provide a succinct answer. 0.9. What is the ratio of the Gross enrolment ratio (%) in Swaziland in 2001 to that in 2007?
Give a very brief answer. 0.78. What is the ratio of the Gross enrolment ratio (%) in Tonga in 2001 to that in 2007?
Make the answer very short. 1.01. What is the ratio of the Gross enrolment ratio (%) in Tunisia in 2001 to that in 2007?
Give a very brief answer. 0.86. What is the ratio of the Gross enrolment ratio (%) in West Bank and Gaza in 2001 to that in 2007?
Your answer should be very brief. 0.91. What is the ratio of the Gross enrolment ratio (%) of Swaziland in 2001 to that in 2009?
Keep it short and to the point. 0.78. What is the ratio of the Gross enrolment ratio (%) in Tonga in 2001 to that in 2009?
Your response must be concise. 1.02. What is the ratio of the Gross enrolment ratio (%) of Tunisia in 2001 to that in 2009?
Offer a very short reply. 0.87. What is the ratio of the Gross enrolment ratio (%) in West Bank and Gaza in 2001 to that in 2009?
Your answer should be very brief. 0.95. What is the ratio of the Gross enrolment ratio (%) in Swaziland in 2002 to that in 2003?
Provide a succinct answer. 1.02. What is the ratio of the Gross enrolment ratio (%) in Tonga in 2002 to that in 2003?
Make the answer very short. 0.92. What is the ratio of the Gross enrolment ratio (%) of West Bank and Gaza in 2002 to that in 2003?
Ensure brevity in your answer.  0.97. What is the ratio of the Gross enrolment ratio (%) of Swaziland in 2002 to that in 2004?
Provide a short and direct response. 0.94. What is the ratio of the Gross enrolment ratio (%) of Tonga in 2002 to that in 2004?
Give a very brief answer. 1.05. What is the ratio of the Gross enrolment ratio (%) of Tunisia in 2002 to that in 2004?
Your response must be concise. 0.96. What is the ratio of the Gross enrolment ratio (%) of West Bank and Gaza in 2002 to that in 2004?
Offer a very short reply. 0.93. What is the ratio of the Gross enrolment ratio (%) of Swaziland in 2002 to that in 2006?
Your answer should be very brief. 0.84. What is the ratio of the Gross enrolment ratio (%) in Tonga in 2002 to that in 2006?
Provide a short and direct response. 1.09. What is the ratio of the Gross enrolment ratio (%) in Tunisia in 2002 to that in 2006?
Offer a very short reply. 0.91. What is the ratio of the Gross enrolment ratio (%) in West Bank and Gaza in 2002 to that in 2006?
Make the answer very short. 0.92. What is the ratio of the Gross enrolment ratio (%) of Swaziland in 2002 to that in 2007?
Provide a succinct answer. 0.78. What is the ratio of the Gross enrolment ratio (%) of Tonga in 2002 to that in 2007?
Offer a terse response. 1.06. What is the ratio of the Gross enrolment ratio (%) of Tunisia in 2002 to that in 2007?
Ensure brevity in your answer.  0.88. What is the ratio of the Gross enrolment ratio (%) of West Bank and Gaza in 2002 to that in 2007?
Your answer should be very brief. 0.93. What is the ratio of the Gross enrolment ratio (%) in Swaziland in 2002 to that in 2009?
Ensure brevity in your answer.  0.78. What is the ratio of the Gross enrolment ratio (%) of Tonga in 2002 to that in 2009?
Your response must be concise. 1.07. What is the ratio of the Gross enrolment ratio (%) of Tunisia in 2002 to that in 2009?
Give a very brief answer. 0.89. What is the ratio of the Gross enrolment ratio (%) of West Bank and Gaza in 2002 to that in 2009?
Your response must be concise. 0.97. What is the ratio of the Gross enrolment ratio (%) in Swaziland in 2003 to that in 2004?
Make the answer very short. 0.93. What is the ratio of the Gross enrolment ratio (%) of Tonga in 2003 to that in 2004?
Offer a terse response. 1.14. What is the ratio of the Gross enrolment ratio (%) in Tunisia in 2003 to that in 2004?
Offer a very short reply. 0.95. What is the ratio of the Gross enrolment ratio (%) of Swaziland in 2003 to that in 2006?
Give a very brief answer. 0.82. What is the ratio of the Gross enrolment ratio (%) in Tonga in 2003 to that in 2006?
Give a very brief answer. 1.18. What is the ratio of the Gross enrolment ratio (%) in Tunisia in 2003 to that in 2006?
Provide a succinct answer. 0.91. What is the ratio of the Gross enrolment ratio (%) in West Bank and Gaza in 2003 to that in 2006?
Offer a very short reply. 0.95. What is the ratio of the Gross enrolment ratio (%) of Swaziland in 2003 to that in 2007?
Your answer should be compact. 0.77. What is the ratio of the Gross enrolment ratio (%) in Tonga in 2003 to that in 2007?
Offer a very short reply. 1.14. What is the ratio of the Gross enrolment ratio (%) in Tunisia in 2003 to that in 2007?
Give a very brief answer. 0.88. What is the ratio of the Gross enrolment ratio (%) of West Bank and Gaza in 2003 to that in 2007?
Offer a very short reply. 0.96. What is the ratio of the Gross enrolment ratio (%) of Swaziland in 2003 to that in 2009?
Give a very brief answer. 0.77. What is the ratio of the Gross enrolment ratio (%) of Tonga in 2003 to that in 2009?
Offer a very short reply. 1.16. What is the ratio of the Gross enrolment ratio (%) of Tunisia in 2003 to that in 2009?
Offer a very short reply. 0.88. What is the ratio of the Gross enrolment ratio (%) of Swaziland in 2004 to that in 2006?
Provide a short and direct response. 0.89. What is the ratio of the Gross enrolment ratio (%) in Tonga in 2004 to that in 2006?
Provide a succinct answer. 1.04. What is the ratio of the Gross enrolment ratio (%) of Tunisia in 2004 to that in 2006?
Offer a very short reply. 0.95. What is the ratio of the Gross enrolment ratio (%) in Swaziland in 2004 to that in 2007?
Keep it short and to the point. 0.83. What is the ratio of the Gross enrolment ratio (%) of Tunisia in 2004 to that in 2007?
Offer a very short reply. 0.92. What is the ratio of the Gross enrolment ratio (%) in Swaziland in 2004 to that in 2009?
Your answer should be very brief. 0.83. What is the ratio of the Gross enrolment ratio (%) in Tonga in 2004 to that in 2009?
Make the answer very short. 1.02. What is the ratio of the Gross enrolment ratio (%) of Tunisia in 2004 to that in 2009?
Your response must be concise. 0.93. What is the ratio of the Gross enrolment ratio (%) of West Bank and Gaza in 2004 to that in 2009?
Offer a very short reply. 1.04. What is the ratio of the Gross enrolment ratio (%) of Swaziland in 2006 to that in 2007?
Give a very brief answer. 0.93. What is the ratio of the Gross enrolment ratio (%) in Tunisia in 2006 to that in 2007?
Make the answer very short. 0.97. What is the ratio of the Gross enrolment ratio (%) of West Bank and Gaza in 2006 to that in 2007?
Offer a terse response. 1.01. What is the ratio of the Gross enrolment ratio (%) of Swaziland in 2006 to that in 2009?
Your response must be concise. 0.93. What is the ratio of the Gross enrolment ratio (%) of Tonga in 2006 to that in 2009?
Provide a succinct answer. 0.98. What is the ratio of the Gross enrolment ratio (%) in Tunisia in 2006 to that in 2009?
Offer a terse response. 0.98. What is the ratio of the Gross enrolment ratio (%) in West Bank and Gaza in 2006 to that in 2009?
Offer a very short reply. 1.05. What is the ratio of the Gross enrolment ratio (%) in Swaziland in 2007 to that in 2009?
Your answer should be compact. 1. What is the ratio of the Gross enrolment ratio (%) in Tunisia in 2007 to that in 2009?
Offer a terse response. 1.01. What is the ratio of the Gross enrolment ratio (%) in West Bank and Gaza in 2007 to that in 2009?
Offer a very short reply. 1.04. What is the difference between the highest and the second highest Gross enrolment ratio (%) of Swaziland?
Offer a terse response. 0.01. What is the difference between the highest and the second highest Gross enrolment ratio (%) of Tonga?
Offer a terse response. 8.99. What is the difference between the highest and the second highest Gross enrolment ratio (%) of Tunisia?
Provide a succinct answer. 0.85. What is the difference between the highest and the second highest Gross enrolment ratio (%) in West Bank and Gaza?
Give a very brief answer. 1.05. What is the difference between the highest and the lowest Gross enrolment ratio (%) in Swaziland?
Your answer should be compact. 12.58. What is the difference between the highest and the lowest Gross enrolment ratio (%) in Tonga?
Ensure brevity in your answer.  18.42. What is the difference between the highest and the lowest Gross enrolment ratio (%) in Tunisia?
Your answer should be compact. 12.67. What is the difference between the highest and the lowest Gross enrolment ratio (%) of West Bank and Gaza?
Give a very brief answer. 9.4. 